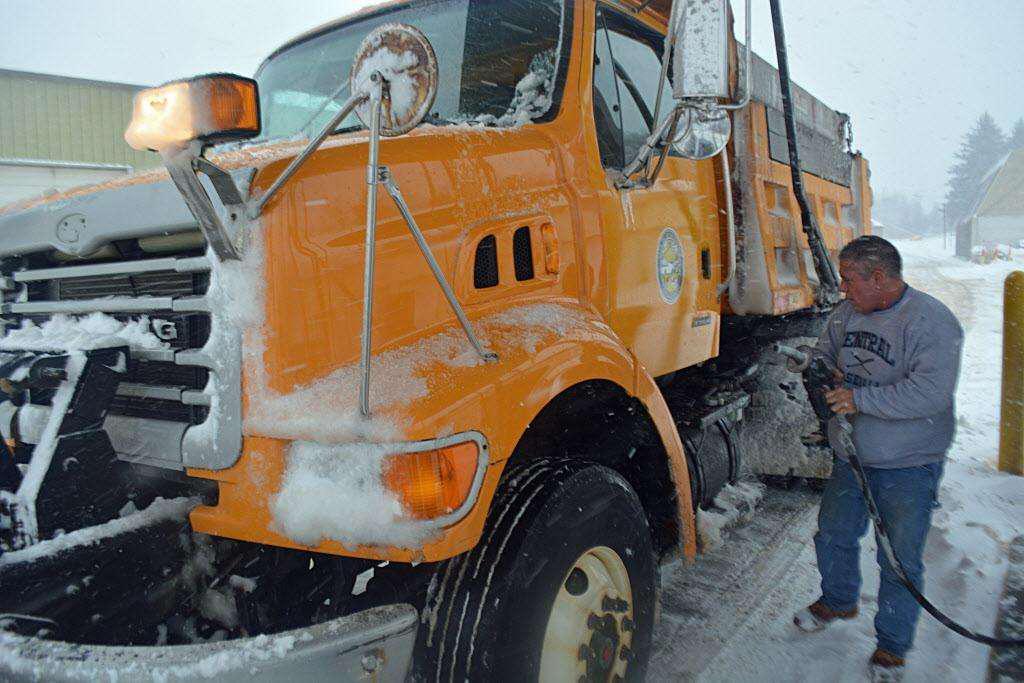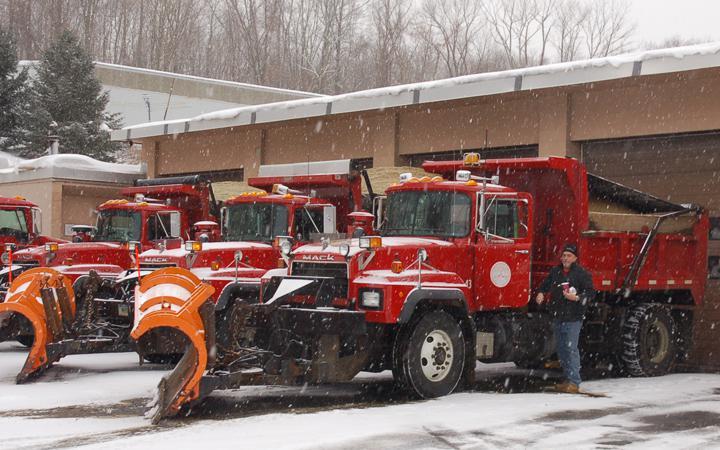The first image is the image on the left, the second image is the image on the right. Evaluate the accuracy of this statement regarding the images: "A truck in each image is equipped with a front-facing orange show blade, but neither truck is plowing snow.". Is it true? Answer yes or no. No. The first image is the image on the left, the second image is the image on the right. Evaluate the accuracy of this statement regarding the images: "Only one of the images features a red truck, with a plow attachment.". Is it true? Answer yes or no. Yes. 